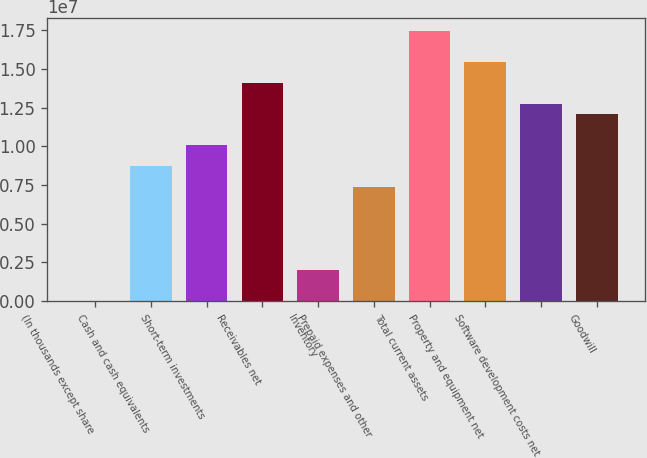Convert chart to OTSL. <chart><loc_0><loc_0><loc_500><loc_500><bar_chart><fcel>(In thousands except share<fcel>Cash and cash equivalents<fcel>Short-term investments<fcel>Receivables net<fcel>Inventory<fcel>Prepaid expenses and other<fcel>Total current assets<fcel>Property and equipment net<fcel>Software development costs net<fcel>Goodwill<nl><fcel>2018<fcel>8.72062e+06<fcel>1.00619e+07<fcel>1.40859e+07<fcel>2.014e+06<fcel>7.3793e+06<fcel>1.74392e+07<fcel>1.54272e+07<fcel>1.27446e+07<fcel>1.20739e+07<nl></chart> 